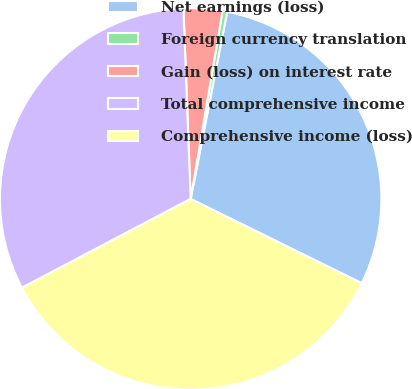Convert chart. <chart><loc_0><loc_0><loc_500><loc_500><pie_chart><fcel>Net earnings (loss)<fcel>Foreign currency translation<fcel>Gain (loss) on interest rate<fcel>Total comprehensive income<fcel>Comprehensive income (loss)<nl><fcel>29.22%<fcel>0.39%<fcel>3.28%<fcel>32.11%<fcel>35.0%<nl></chart> 